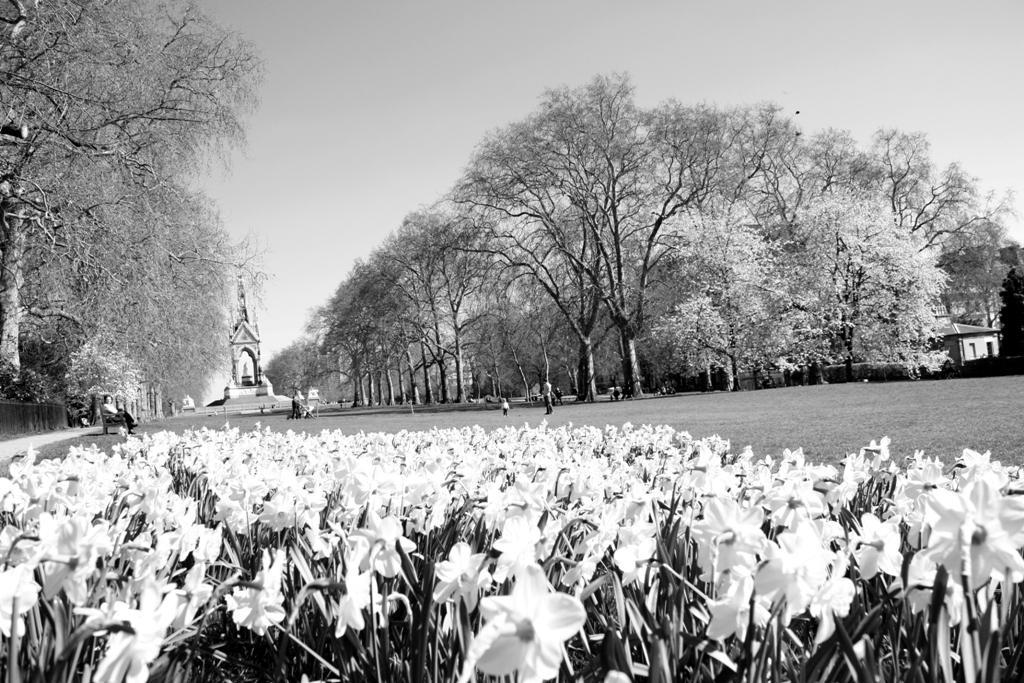How would you summarize this image in a sentence or two? At the bottom of the image there are some plants and flowers. In the middle of the image few people are standing and sitting. Behind them there are some trees and buildings. At the top of the image there is sky. 